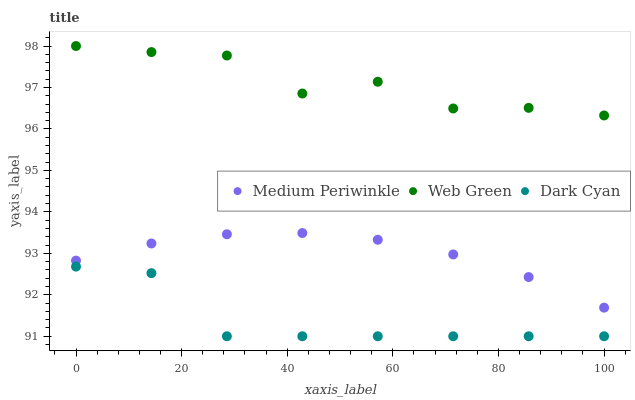Does Dark Cyan have the minimum area under the curve?
Answer yes or no. Yes. Does Web Green have the maximum area under the curve?
Answer yes or no. Yes. Does Medium Periwinkle have the minimum area under the curve?
Answer yes or no. No. Does Medium Periwinkle have the maximum area under the curve?
Answer yes or no. No. Is Medium Periwinkle the smoothest?
Answer yes or no. Yes. Is Web Green the roughest?
Answer yes or no. Yes. Is Web Green the smoothest?
Answer yes or no. No. Is Medium Periwinkle the roughest?
Answer yes or no. No. Does Dark Cyan have the lowest value?
Answer yes or no. Yes. Does Medium Periwinkle have the lowest value?
Answer yes or no. No. Does Web Green have the highest value?
Answer yes or no. Yes. Does Medium Periwinkle have the highest value?
Answer yes or no. No. Is Dark Cyan less than Medium Periwinkle?
Answer yes or no. Yes. Is Web Green greater than Dark Cyan?
Answer yes or no. Yes. Does Dark Cyan intersect Medium Periwinkle?
Answer yes or no. No. 